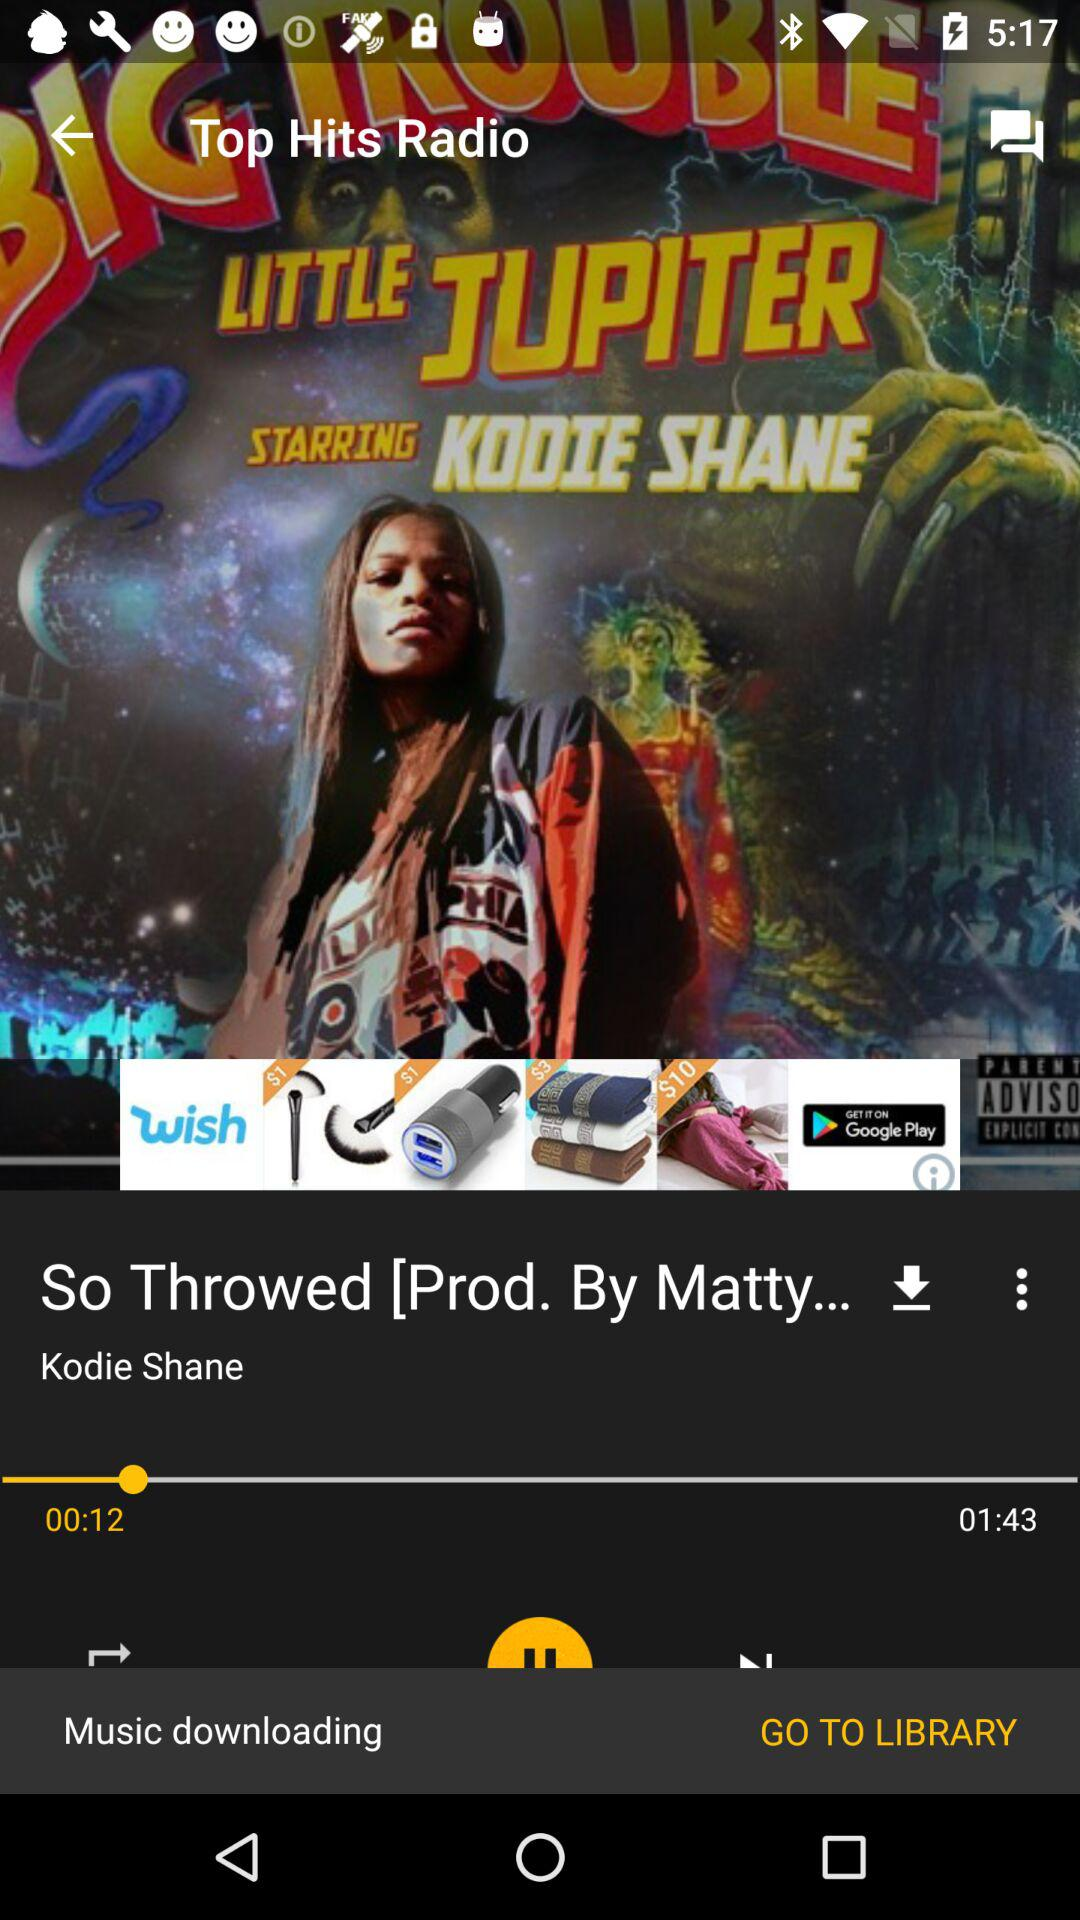What is the time duration of the song? The time duration of the song is 1 minute 43 seconds. 